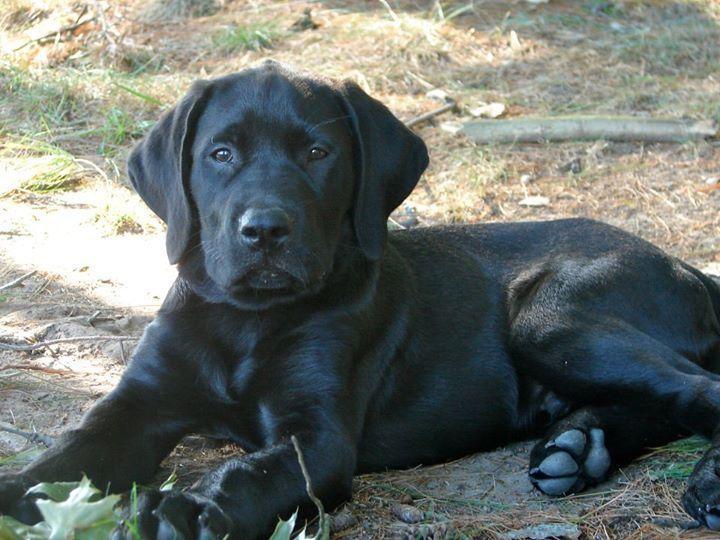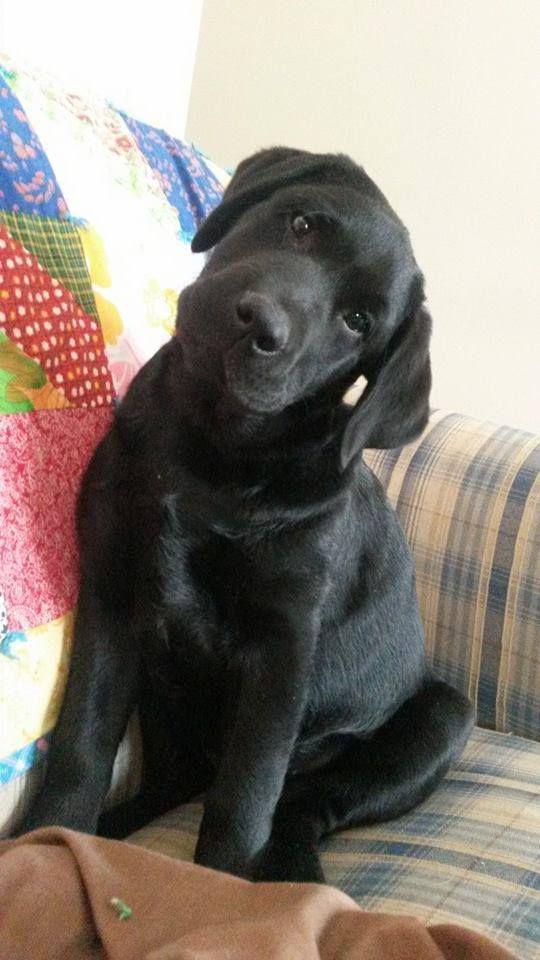The first image is the image on the left, the second image is the image on the right. Considering the images on both sides, is "A dog is lying on a couch with its head down." valid? Answer yes or no. No. The first image is the image on the left, the second image is the image on the right. For the images shown, is this caption "An image shows two dogs reclining together on something indoors, with a white fabric under them." true? Answer yes or no. No. 